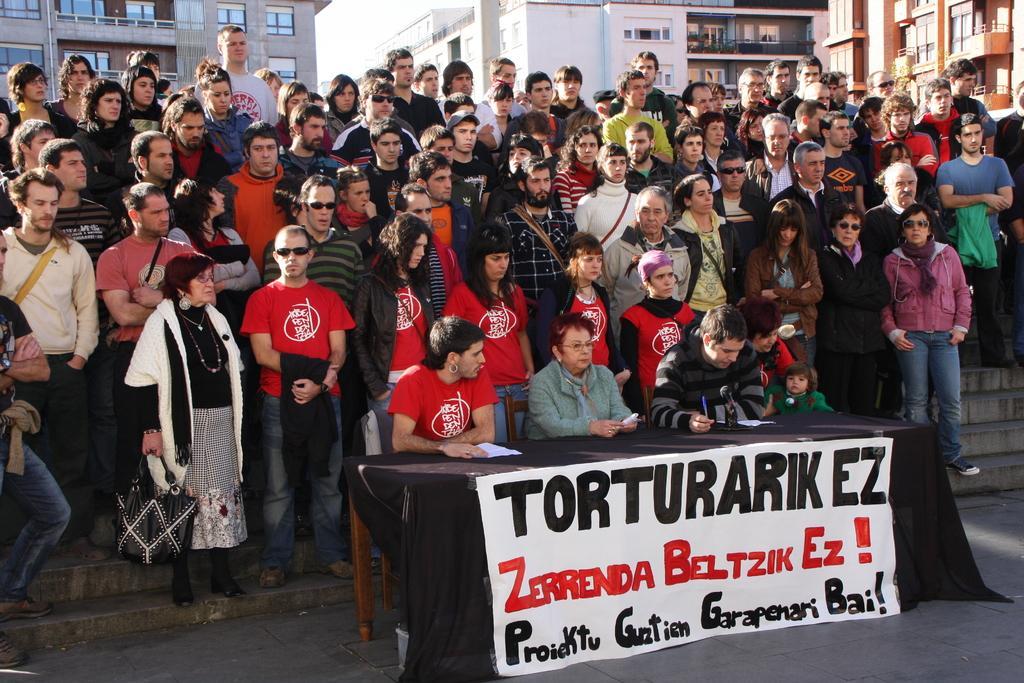How would you summarize this image in a sentence or two? In this image there are many people standing on the steps. In front of them there are four people sitting on the chairs at the table. On the table there is a cloth spread. On the cloth there is a banner sticker. There is text on the banner. In the background there are buildings. At the top there is the sky. 